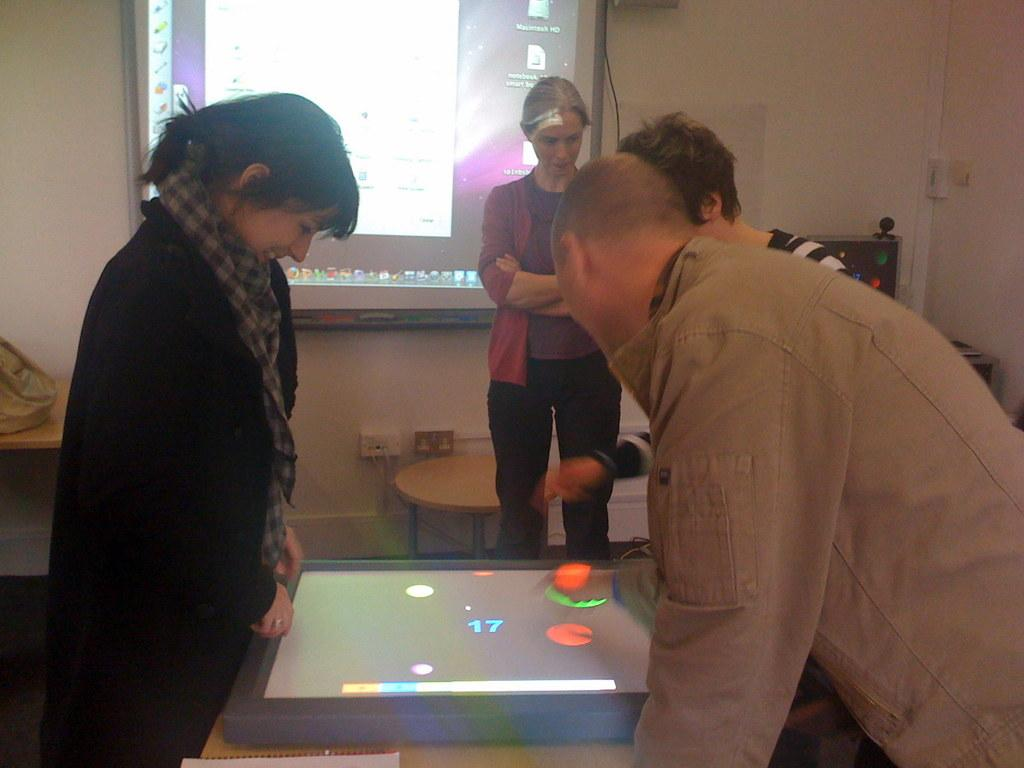What are the people in the image doing? The people in the image are looking at a screen. Can you describe the background of the image? There is another screen visible in the background. What is the position of the woman in the image? A woman is standing in front of the screens. How many planes can be seen flying in the image? There are no planes visible in the image; it features people looking at screens and a woman standing in front of them. 